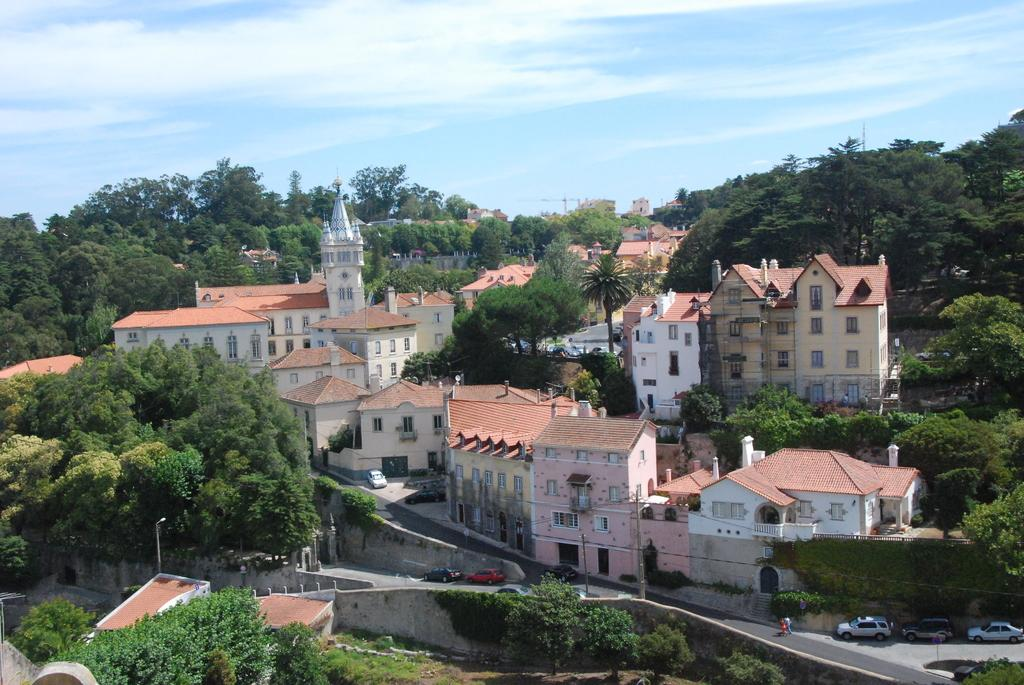What type of view is shown in the image? The image is an aerial view of a city or town. What natural elements can be seen in the image? There are trees in the image. What man-made structures are visible in the image? There are buildings, cars, street lights, and roads in the image. What is the condition of the sky in the image? The sky is partially cloudy in the image. Can you see a quill being used to write on a piece of paper in the image? There is no quill or paper visible in the image; it is an aerial view of a city or town. What type of liquid is being poured from a container in the image? There is no liquid being poured in the image; it only shows an aerial view of a city or town. 